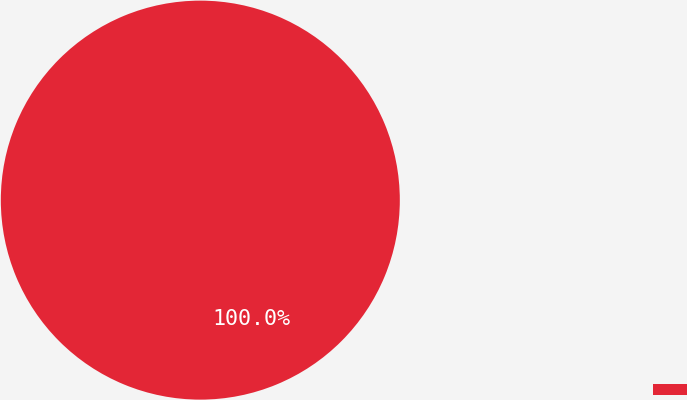<chart> <loc_0><loc_0><loc_500><loc_500><pie_chart><ecel><nl><fcel>100.0%<nl></chart> 